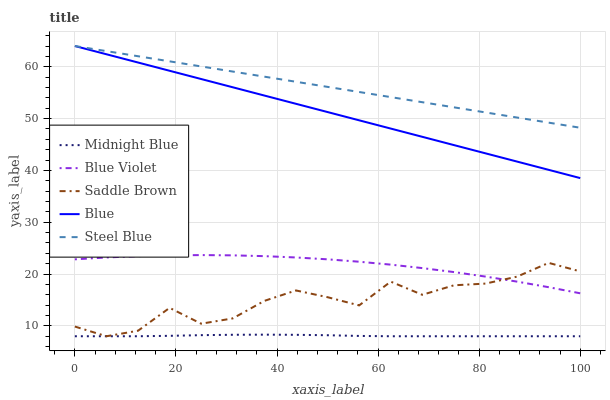Does Midnight Blue have the minimum area under the curve?
Answer yes or no. Yes. Does Steel Blue have the maximum area under the curve?
Answer yes or no. Yes. Does Steel Blue have the minimum area under the curve?
Answer yes or no. No. Does Midnight Blue have the maximum area under the curve?
Answer yes or no. No. Is Steel Blue the smoothest?
Answer yes or no. Yes. Is Saddle Brown the roughest?
Answer yes or no. Yes. Is Midnight Blue the smoothest?
Answer yes or no. No. Is Midnight Blue the roughest?
Answer yes or no. No. Does Midnight Blue have the lowest value?
Answer yes or no. Yes. Does Steel Blue have the lowest value?
Answer yes or no. No. Does Steel Blue have the highest value?
Answer yes or no. Yes. Does Midnight Blue have the highest value?
Answer yes or no. No. Is Midnight Blue less than Steel Blue?
Answer yes or no. Yes. Is Blue greater than Midnight Blue?
Answer yes or no. Yes. Does Saddle Brown intersect Blue Violet?
Answer yes or no. Yes. Is Saddle Brown less than Blue Violet?
Answer yes or no. No. Is Saddle Brown greater than Blue Violet?
Answer yes or no. No. Does Midnight Blue intersect Steel Blue?
Answer yes or no. No. 